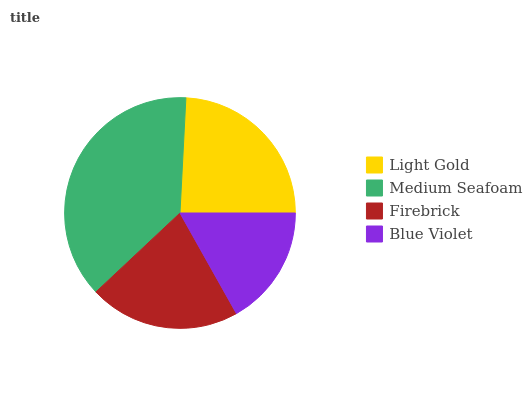Is Blue Violet the minimum?
Answer yes or no. Yes. Is Medium Seafoam the maximum?
Answer yes or no. Yes. Is Firebrick the minimum?
Answer yes or no. No. Is Firebrick the maximum?
Answer yes or no. No. Is Medium Seafoam greater than Firebrick?
Answer yes or no. Yes. Is Firebrick less than Medium Seafoam?
Answer yes or no. Yes. Is Firebrick greater than Medium Seafoam?
Answer yes or no. No. Is Medium Seafoam less than Firebrick?
Answer yes or no. No. Is Light Gold the high median?
Answer yes or no. Yes. Is Firebrick the low median?
Answer yes or no. Yes. Is Medium Seafoam the high median?
Answer yes or no. No. Is Blue Violet the low median?
Answer yes or no. No. 